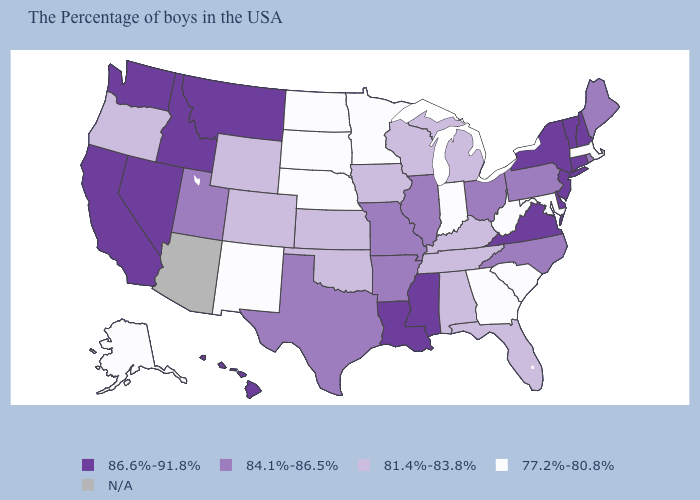What is the value of West Virginia?
Quick response, please. 77.2%-80.8%. What is the value of Rhode Island?
Answer briefly. 84.1%-86.5%. What is the highest value in the USA?
Keep it brief. 86.6%-91.8%. Among the states that border Wisconsin , which have the highest value?
Be succinct. Illinois. Which states have the lowest value in the USA?
Be succinct. Massachusetts, Maryland, South Carolina, West Virginia, Georgia, Indiana, Minnesota, Nebraska, South Dakota, North Dakota, New Mexico, Alaska. Is the legend a continuous bar?
Write a very short answer. No. Among the states that border West Virginia , which have the lowest value?
Answer briefly. Maryland. What is the value of Iowa?
Give a very brief answer. 81.4%-83.8%. Among the states that border Massachusetts , which have the highest value?
Quick response, please. New Hampshire, Vermont, Connecticut, New York. Which states have the lowest value in the USA?
Keep it brief. Massachusetts, Maryland, South Carolina, West Virginia, Georgia, Indiana, Minnesota, Nebraska, South Dakota, North Dakota, New Mexico, Alaska. What is the value of Massachusetts?
Quick response, please. 77.2%-80.8%. Among the states that border Rhode Island , which have the lowest value?
Quick response, please. Massachusetts. Name the states that have a value in the range 86.6%-91.8%?
Keep it brief. New Hampshire, Vermont, Connecticut, New York, New Jersey, Delaware, Virginia, Mississippi, Louisiana, Montana, Idaho, Nevada, California, Washington, Hawaii. Name the states that have a value in the range 86.6%-91.8%?
Give a very brief answer. New Hampshire, Vermont, Connecticut, New York, New Jersey, Delaware, Virginia, Mississippi, Louisiana, Montana, Idaho, Nevada, California, Washington, Hawaii. Which states hav the highest value in the South?
Write a very short answer. Delaware, Virginia, Mississippi, Louisiana. 